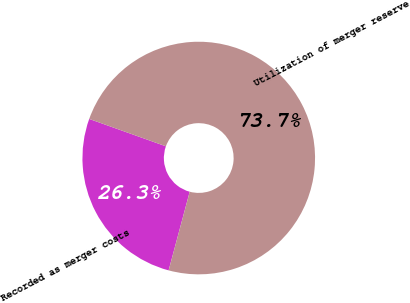<chart> <loc_0><loc_0><loc_500><loc_500><pie_chart><fcel>Recorded as merger costs<fcel>Utilization of merger reserve<nl><fcel>26.29%<fcel>73.71%<nl></chart> 